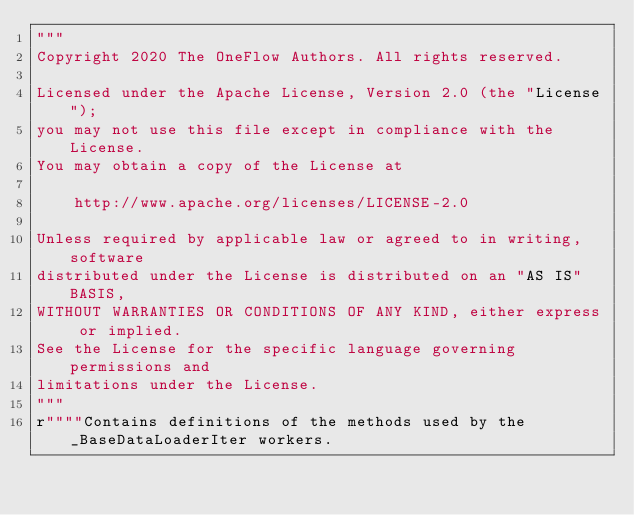<code> <loc_0><loc_0><loc_500><loc_500><_Python_>"""
Copyright 2020 The OneFlow Authors. All rights reserved.

Licensed under the Apache License, Version 2.0 (the "License");
you may not use this file except in compliance with the License.
You may obtain a copy of the License at

    http://www.apache.org/licenses/LICENSE-2.0

Unless required by applicable law or agreed to in writing, software
distributed under the License is distributed on an "AS IS" BASIS,
WITHOUT WARRANTIES OR CONDITIONS OF ANY KIND, either express or implied.
See the License for the specific language governing permissions and
limitations under the License.
"""
r""""Contains definitions of the methods used by the _BaseDataLoaderIter workers.</code> 